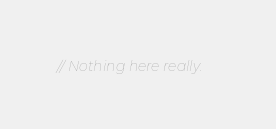<code> <loc_0><loc_0><loc_500><loc_500><_C_>
// Nothing here really.
</code> 